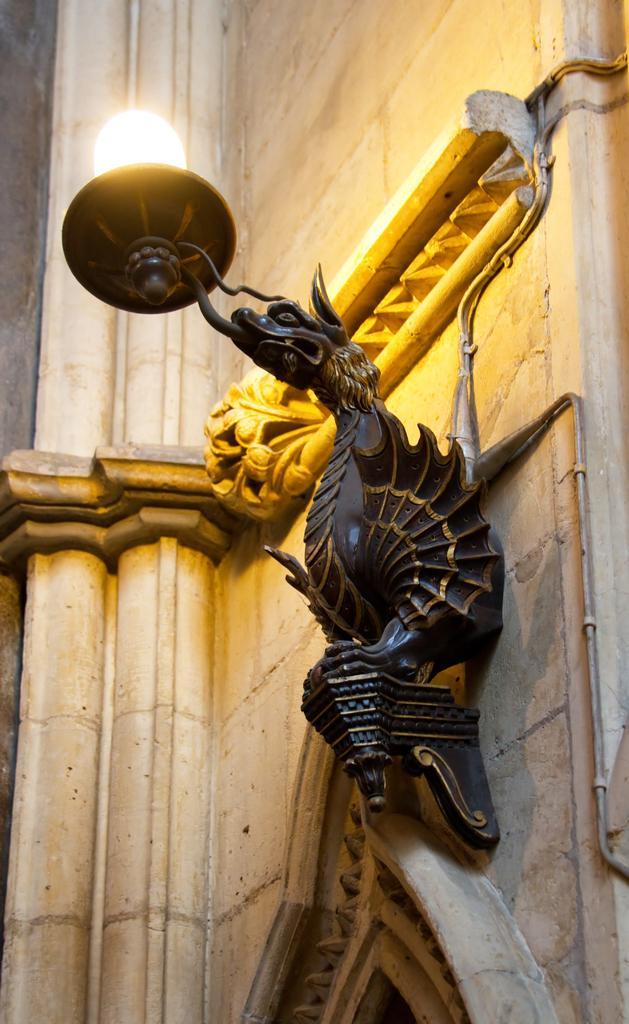Describe this image in one or two sentences. In the foreground of this image, there is a lamp light to the wall. On the bottom, it seems like an arch. 